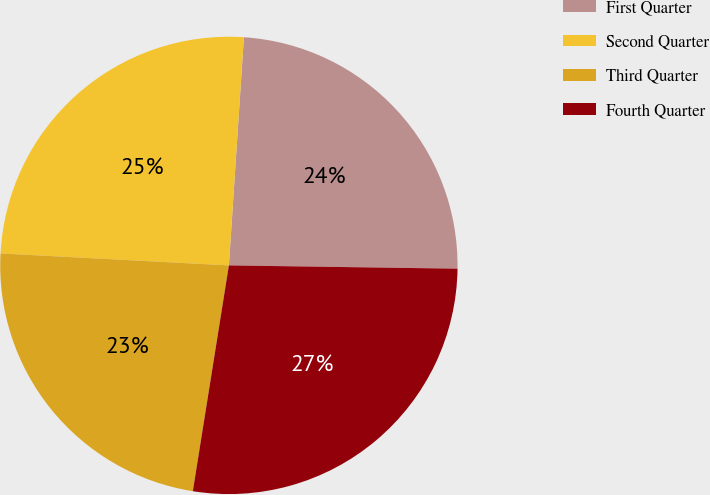Convert chart to OTSL. <chart><loc_0><loc_0><loc_500><loc_500><pie_chart><fcel>First Quarter<fcel>Second Quarter<fcel>Third Quarter<fcel>Fourth Quarter<nl><fcel>24.18%<fcel>25.21%<fcel>23.31%<fcel>27.29%<nl></chart> 